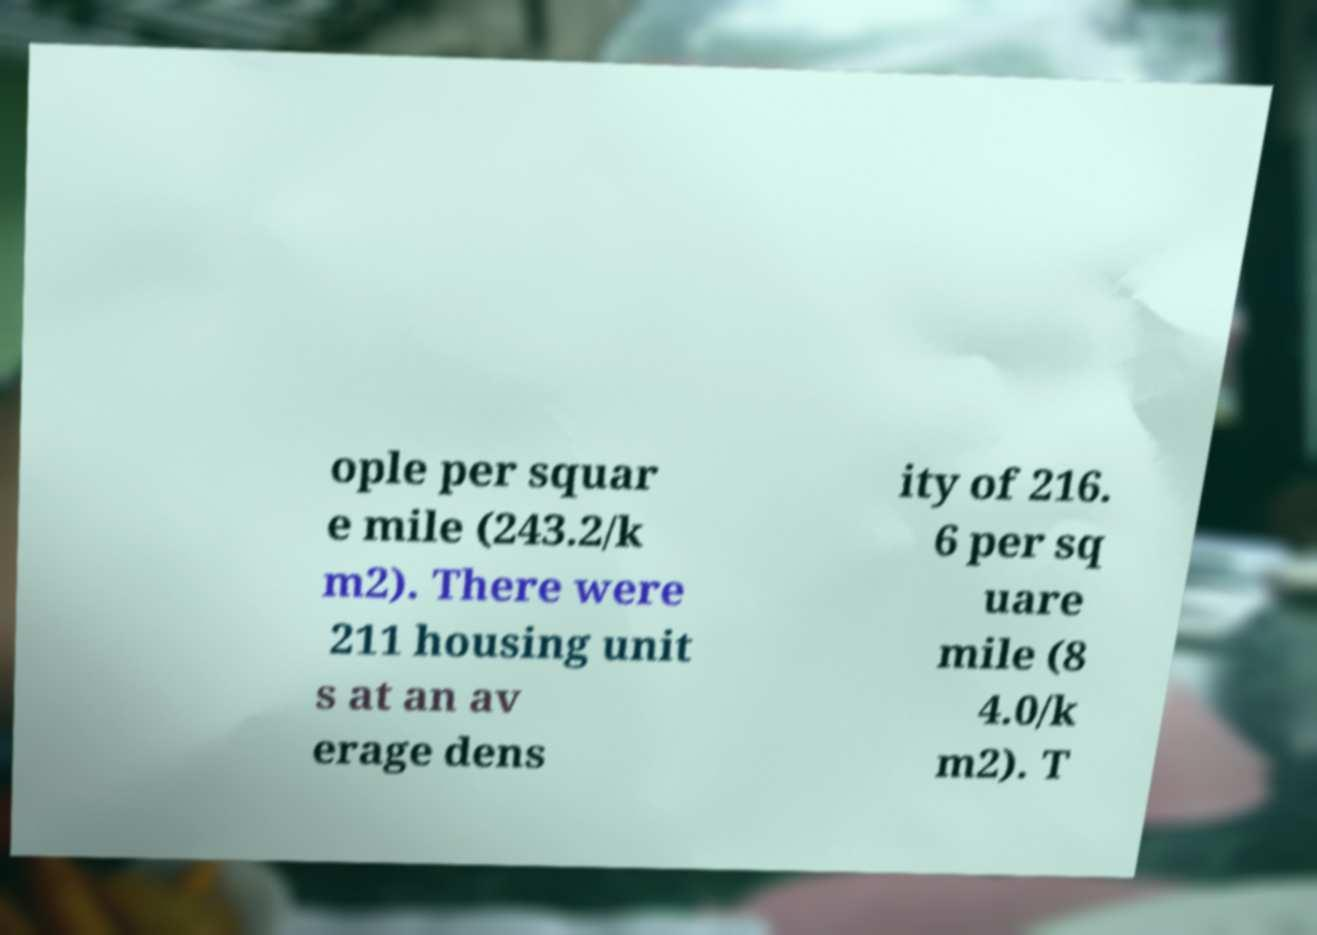For documentation purposes, I need the text within this image transcribed. Could you provide that? ople per squar e mile (243.2/k m2). There were 211 housing unit s at an av erage dens ity of 216. 6 per sq uare mile (8 4.0/k m2). T 